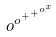Convert formula to latex. <formula><loc_0><loc_0><loc_500><loc_500>o ^ { o ^ { + ^ { + ^ { o ^ { x } } } } }</formula> 